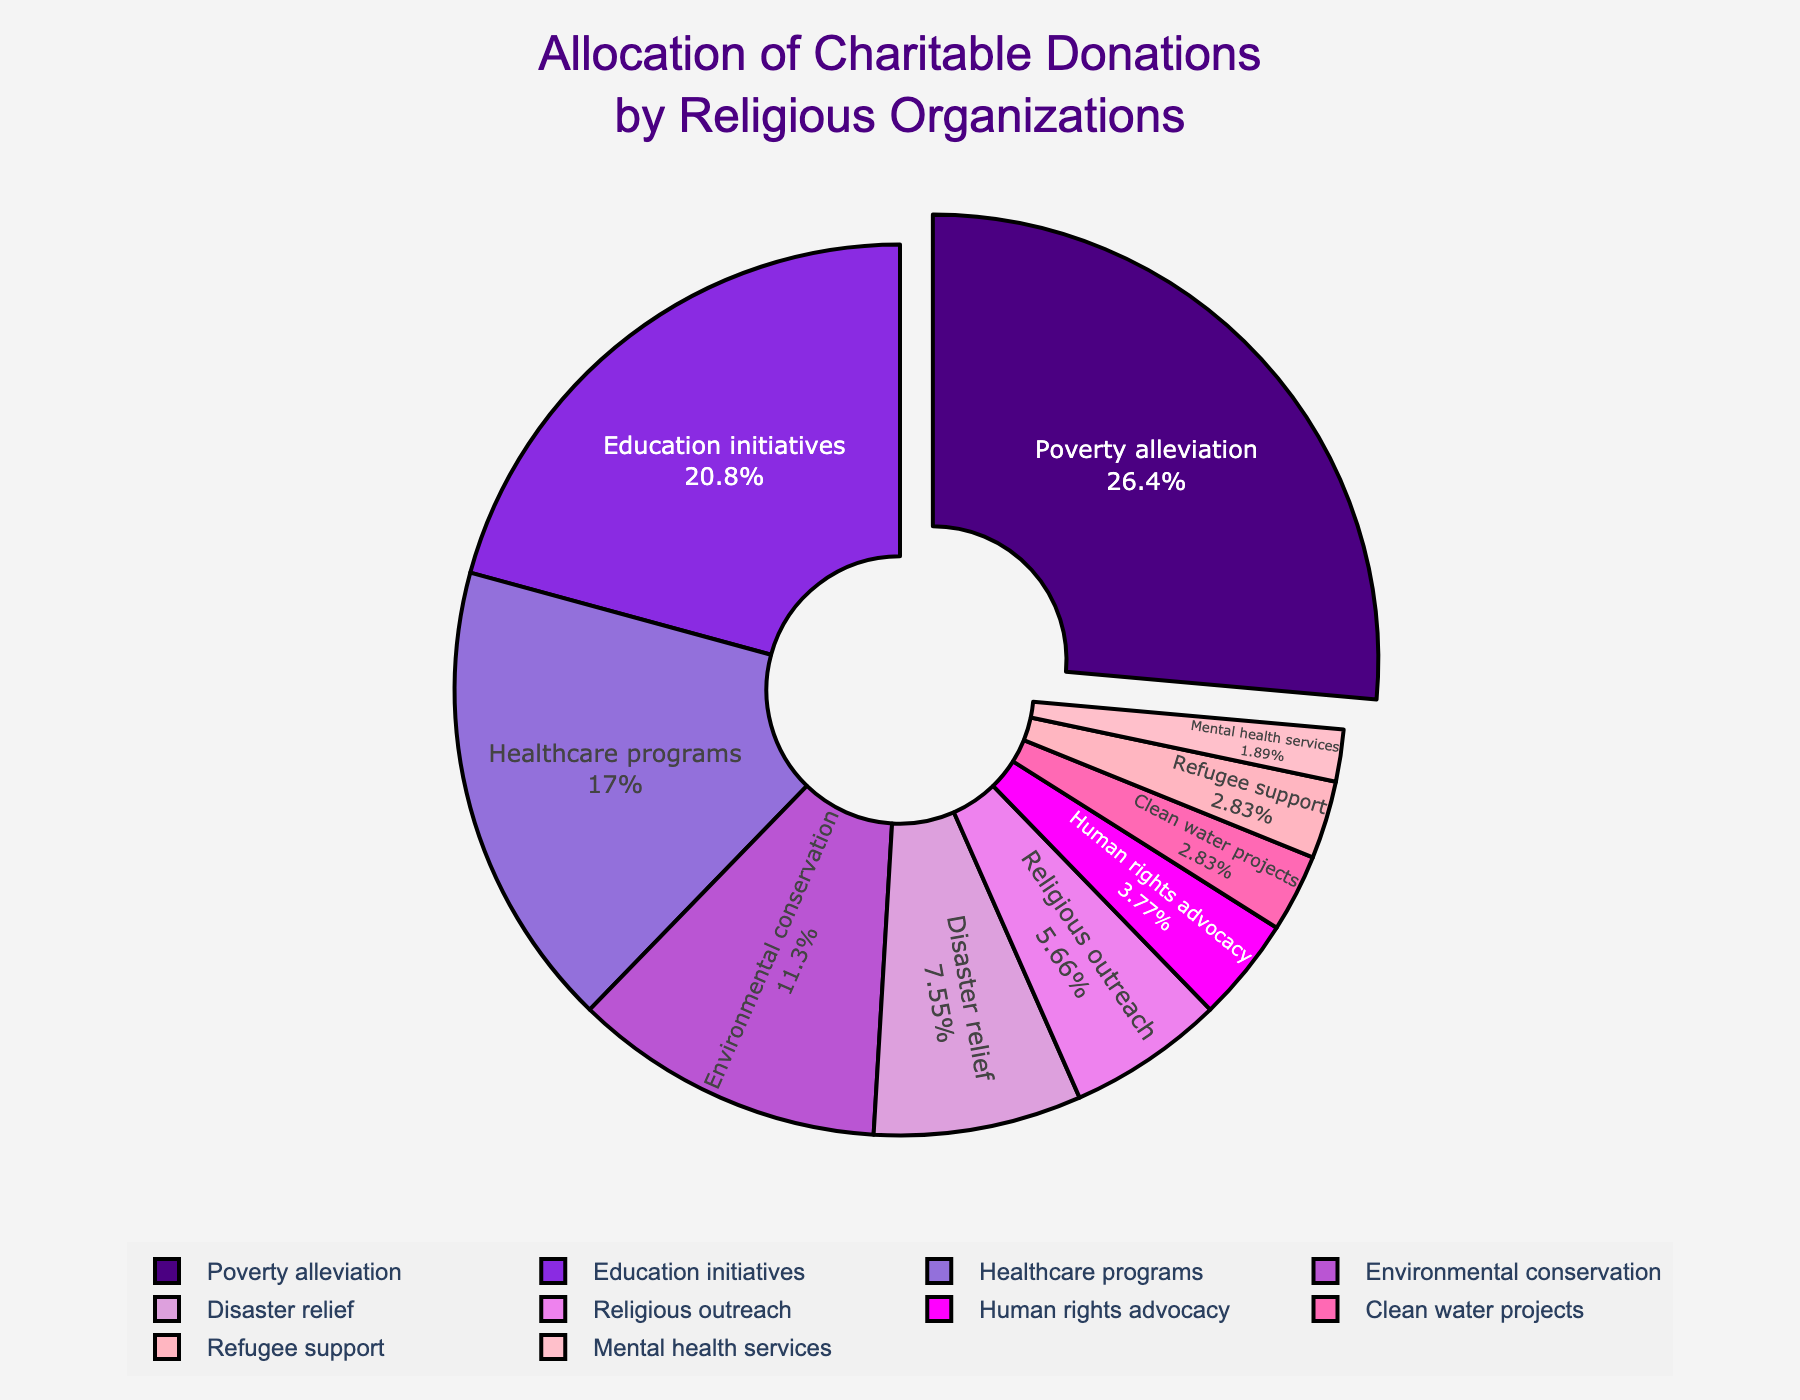Which cause receives the highest percentage of donations? By examining the pie chart, we can see that poverty alleviation receives the highest percentage, which is 28%.
Answer: Poverty alleviation Which two causes combined equal the donation percentage for healthcare programs? Healthcare programs receive 18% of the donations. Combining the two smallest segments, mental health services (2%) and refugee support (3%), we get 2% + 3% = 5%. Thus, we continue to add other segments until we find the combination that sums up to 18%. Clean water projects (3%) and human rights advocacy (4%) together are 7%, which still isn't sufficient. Adding religious outreach (6%) brings the total to 13%. Finally, adding disaster relief (8%) makes the total 21%, which exceeds the needed amount. Upon continuing, it's clear that combining environmental conservation (12%) with disaster relief (8%) equals 20%, which still exceeds. Continuing in a reverse approach, we find that combining religious outreach (6%) and environmental conservation (12%) equals 18%.
Answer: Religious outreach and environmental conservation How much more in percentage is allocated to education initiatives than to environmental conservation? Education initiatives receive 22% of donations, while environmental conservation receives 12%. The difference is calculated as 22% - 12% = 10%.
Answer: 10% Which cause receives the least percentage of donations, and what is its percentage? The smallest segment in the pie chart represents mental health services with 2% of the donations.
Answer: Mental health services, 2% List the causes that receive less than 5% of the total donations. By examining the chart, we identify that human rights advocacy (4%), clean water projects (3%), refugee support (3%), and mental health services (2%) each receive less than 5% of the donations.
Answer: Human rights advocacy, clean water projects, refugee support, mental health services What percentage of donations is allocated to causes other than poverty alleviation and education initiatives? Combining the percentages of all causes excluding poverty alleviation and education initiatives: 18% (healthcare) + 12% (environmental conservation) + 8% (disaster relief) + 6% (religious outreach) + 4% (human rights advocacy) + 3% (clean water projects) + 3% (refugee support) + 2% (mental health services) = 56%.
Answer: 56% Which color represents "disaster relief" on the pie chart? The pie chart shows that disaster relief is represented by the light purple color, which stands out as the segment labeled with the corresponding percentage of 8%.
Answer: Light purple What's the total percentage of donations allocated to healthcare programs and disaster relief combined? Healthcare programs receive 18%, and disaster relief receives 8%. Adding these together results in 18% + 8% = 26%.
Answer: 26% If the donations to religious outreach and human rights advocacy were combined, what percentage of the total would they represent? Adding the percentages for religious outreach (6%) and human rights advocacy (4%), the combined percentage would be 6% + 4% = 10%.
Answer: 10% 